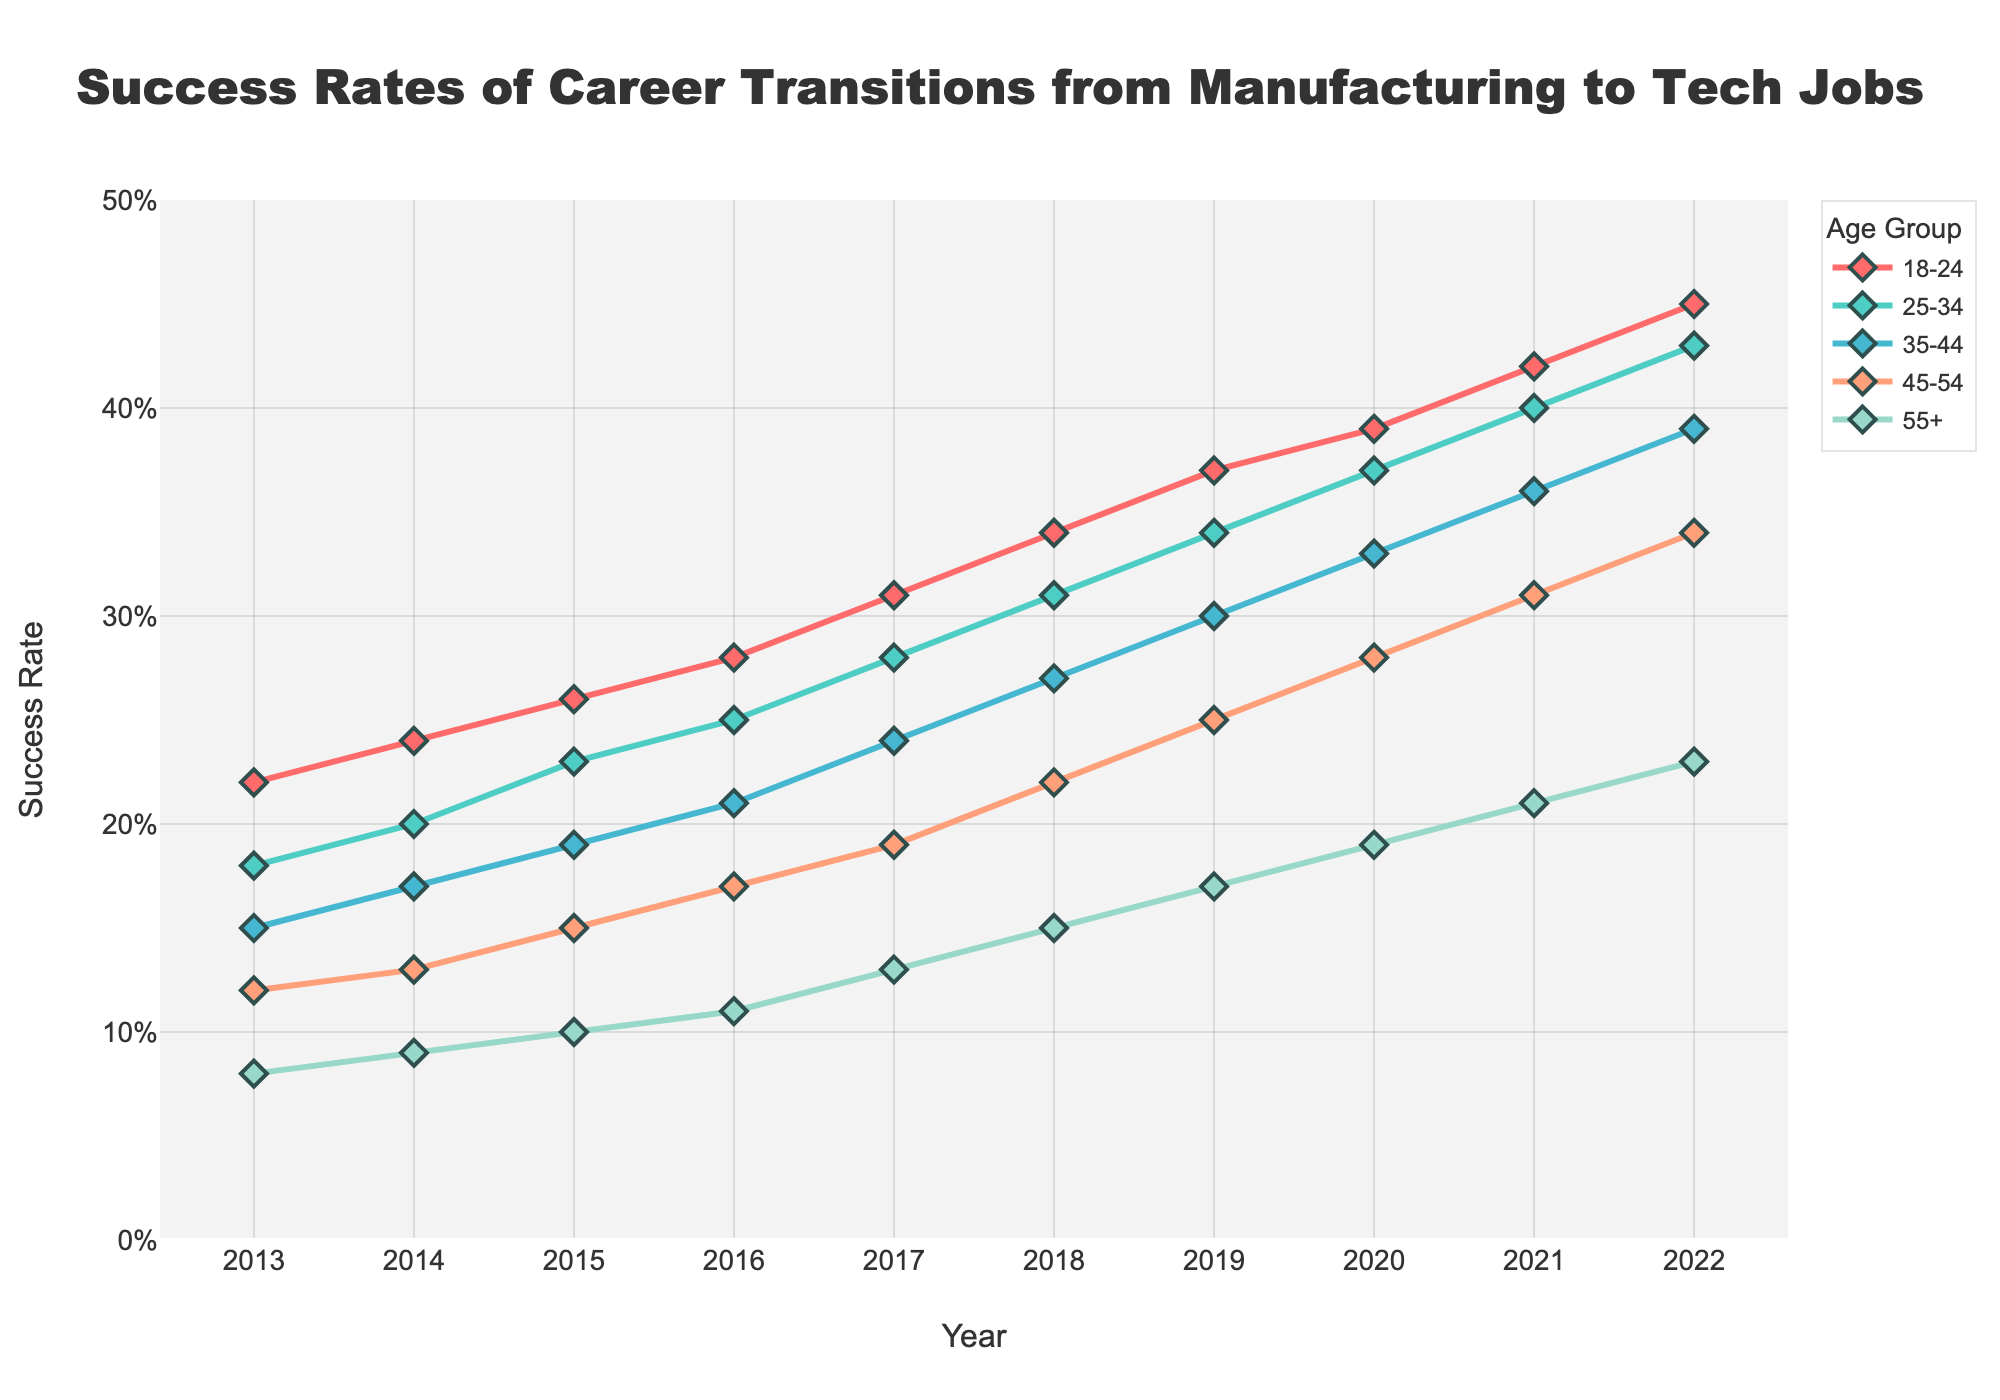What age group showed the highest success rate in 2013? The success rate for each age group in 2013 is shown along the y-axis. The data shows the highest rate for the 18-24 age group
Answer: 18-24 Which age group had the largest increase in success rate from 2013 to 2022? Calculate the difference in success rates between 2022 and 2013 for each age group. The values are: 45%-22% = 23%, 43%-18% = 25%, 39%-15% = 24%, 34%-12% = 22%, and 23%-8% = 15%. The largest increase is in the 25-34 age group
Answer: 25-34 Is the success rate for the 45-54 age group in 2017 higher or lower than the success rate for the 55+ age group in 2022? Refer to the success rates for each group in the respective years: 45-54 age group in 2017 has a success rate of 19% and the 55+ age group in 2022 has a success rate of 23%
Answer: Lower What is the average success rate across all age groups in 2020? Calculate the mean of the success rates in 2020: (39% + 37% + 33% + 28% + 19%) / 5 = 31.2%
Answer: 31.2% In which year did the 25-34 age group first surpass the 30% success rate? Look at the success rates for the 25-34 age group over the years. They first surpassed 30% in 2018
Answer: 2018 Which age group's success rates have consistently increased every year from 2013 to 2022? Analyze the success rates for each age group across the years. All age groups consistently show an increase every year from 2013 to 2022
Answer: All age groups How much greater is the success rate for the 18-24 age group compared to the 55+ age group in 2022? Compare the success rates in 2022: 18-24 age group has a rate of 45%, and the 55+ age group has a rate of 23%. The difference is 45% - 23% = 22%
Answer: 22% What is the trend in success rates for the 35-44 age group from 2013 to 2022? The success rate increases steadily every year from 15% in 2013 to 39% in 2022
Answer: Increasing Which age group had the lowest success rate in 2016, and what was it? Observe the success rates for 2016 across all age groups. The lowest is for the 55+ age group at 11%
Answer: 55+, 11% By how much did the success rate for the 45-54 age group increase from 2016 to 2020? Calculate the difference between the success rates in 2020 and 2016 for the 45-54 age group: 28% - 17% = 11%
Answer: 11% 